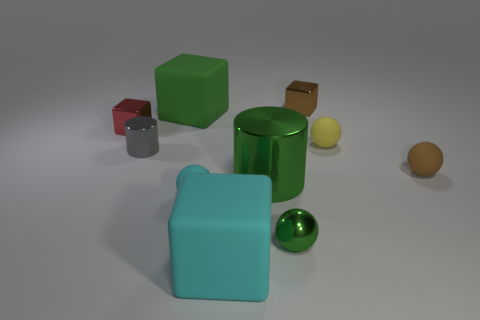What number of blocks are the same color as the shiny ball?
Your response must be concise. 1. Is the number of tiny brown matte things less than the number of tiny metallic blocks?
Ensure brevity in your answer.  Yes. Do the small cylinder and the cyan sphere have the same material?
Your answer should be compact. No. How many other things are the same size as the green metal sphere?
Ensure brevity in your answer.  6. The large rubber object on the right side of the big green thing to the left of the cyan block is what color?
Keep it short and to the point. Cyan. What number of other objects are the same shape as the small yellow rubber thing?
Ensure brevity in your answer.  3. Is there a tiny gray sphere that has the same material as the tiny green object?
Provide a succinct answer. No. There is a yellow ball that is the same size as the brown metal cube; what is its material?
Your response must be concise. Rubber. What color is the large cube in front of the red metal object that is behind the tiny rubber ball to the left of the brown metallic thing?
Provide a short and direct response. Cyan. Is the shape of the green metal thing that is in front of the small cyan matte ball the same as the large thing on the left side of the big cyan thing?
Ensure brevity in your answer.  No. 